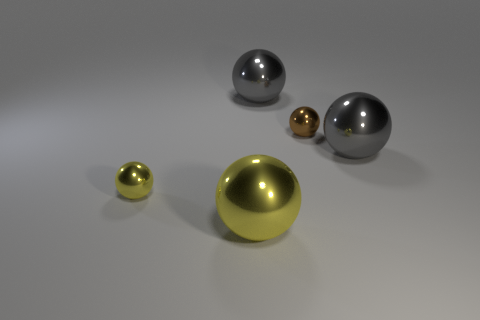Subtract all tiny brown balls. How many balls are left? 4 Subtract all brown balls. How many balls are left? 4 Subtract 1 spheres. How many spheres are left? 4 Add 2 yellow metallic cylinders. How many objects exist? 7 Subtract all purple balls. Subtract all yellow blocks. How many balls are left? 5 Add 3 objects. How many objects are left? 8 Add 2 small brown shiny balls. How many small brown shiny balls exist? 3 Subtract 0 purple cubes. How many objects are left? 5 Subtract all large gray objects. Subtract all big things. How many objects are left? 0 